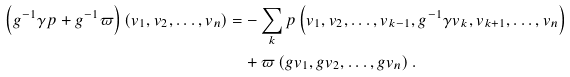<formula> <loc_0><loc_0><loc_500><loc_500>\left ( g ^ { - 1 } \gamma p + g ^ { - 1 } \varpi \right ) \left ( v _ { 1 } , v _ { 2 } , \dots , v _ { n } \right ) = & - \sum _ { k } p \left ( v _ { 1 } , v _ { 2 } , \dots , v _ { k - 1 } , g ^ { - 1 } \gamma v _ { k } , v _ { k + 1 } , \dots , v _ { n } \right ) \\ & + \varpi \left ( g v _ { 1 } , g v _ { 2 } , \dots , g v _ { n } \right ) .</formula> 